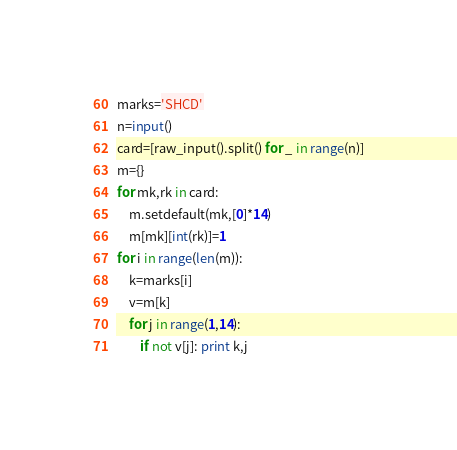<code> <loc_0><loc_0><loc_500><loc_500><_Python_>marks='SHCD'
n=input()
card=[raw_input().split() for _ in range(n)]
m={}
for mk,rk in card:
    m.setdefault(mk,[0]*14)
    m[mk][int(rk)]=1
for i in range(len(m)):
    k=marks[i]
    v=m[k]
    for j in range(1,14):
        if not v[j]: print k,j</code> 